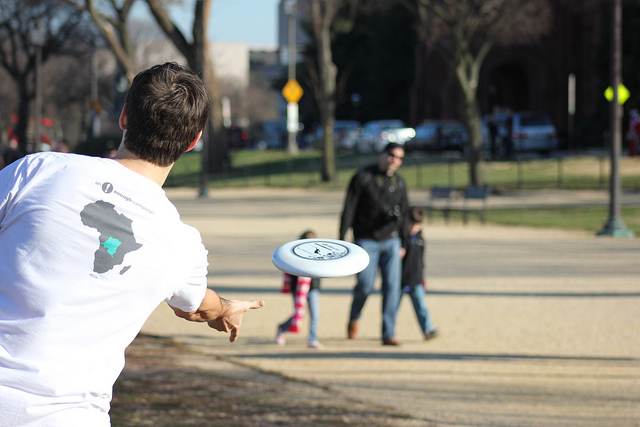How many cows are directly facing the camera? 0 